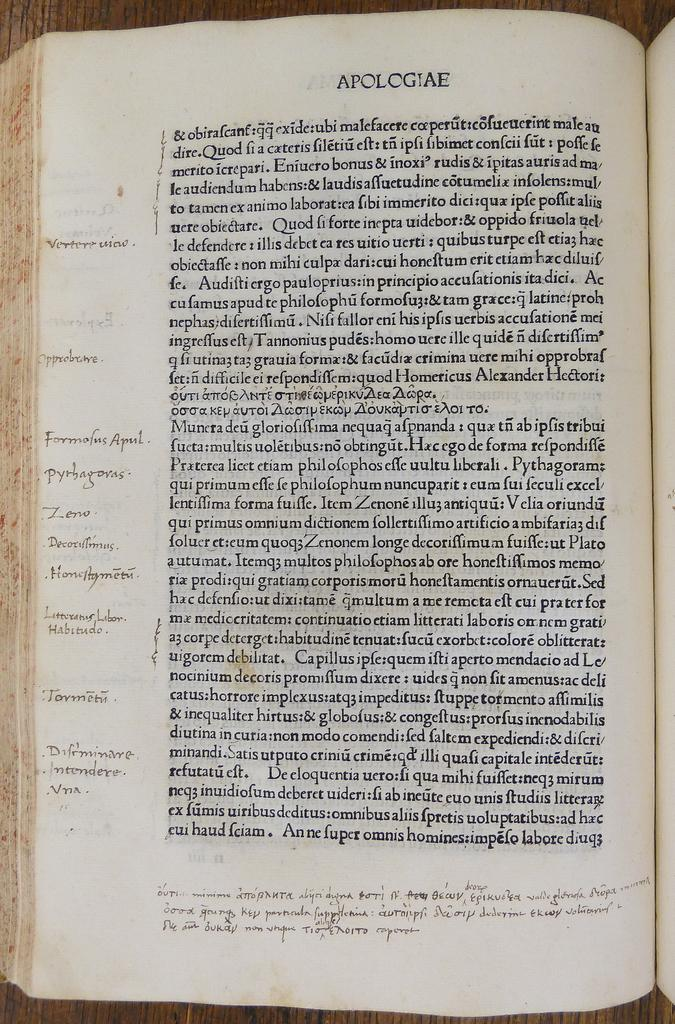<image>
Provide a brief description of the given image. An antique looking book is opened up to a worn page that is titled Apologiae, and the text is written in a foreign language. 